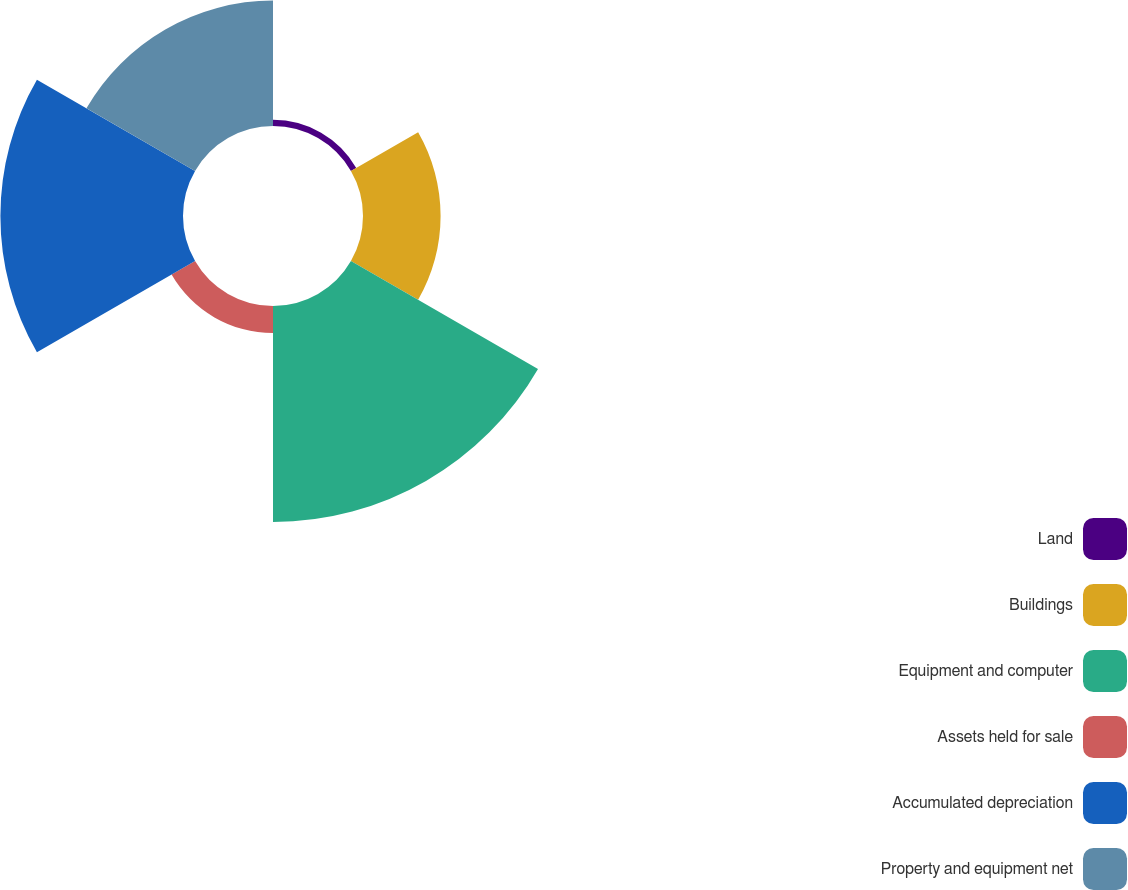Convert chart. <chart><loc_0><loc_0><loc_500><loc_500><pie_chart><fcel>Land<fcel>Buildings<fcel>Equipment and computer<fcel>Assets held for sale<fcel>Accumulated depreciation<fcel>Property and equipment net<nl><fcel>0.97%<fcel>12.22%<fcel>34.02%<fcel>4.27%<fcel>28.76%<fcel>19.75%<nl></chart> 